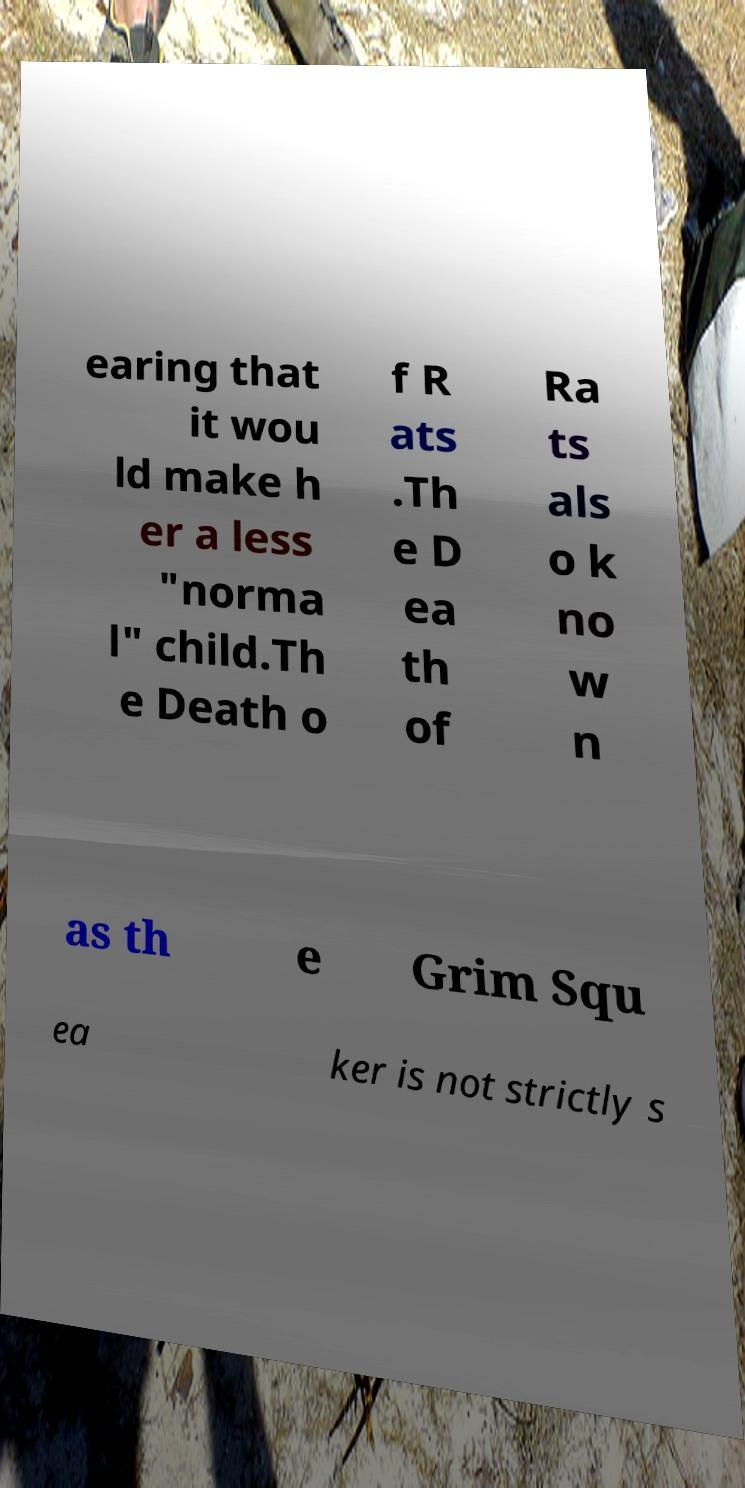Please read and relay the text visible in this image. What does it say? earing that it wou ld make h er a less "norma l" child.Th e Death o f R ats .Th e D ea th of Ra ts als o k no w n as th e Grim Squ ea ker is not strictly s 